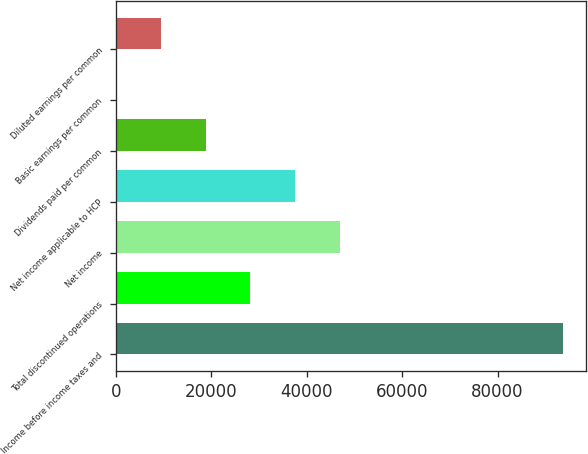Convert chart. <chart><loc_0><loc_0><loc_500><loc_500><bar_chart><fcel>Income before income taxes and<fcel>Total discontinued operations<fcel>Net income<fcel>Net income applicable to HCP<fcel>Dividends paid per common<fcel>Basic earnings per common<fcel>Diluted earnings per common<nl><fcel>93778<fcel>28133.4<fcel>46889<fcel>37511.2<fcel>18755.6<fcel>0.05<fcel>9377.84<nl></chart> 